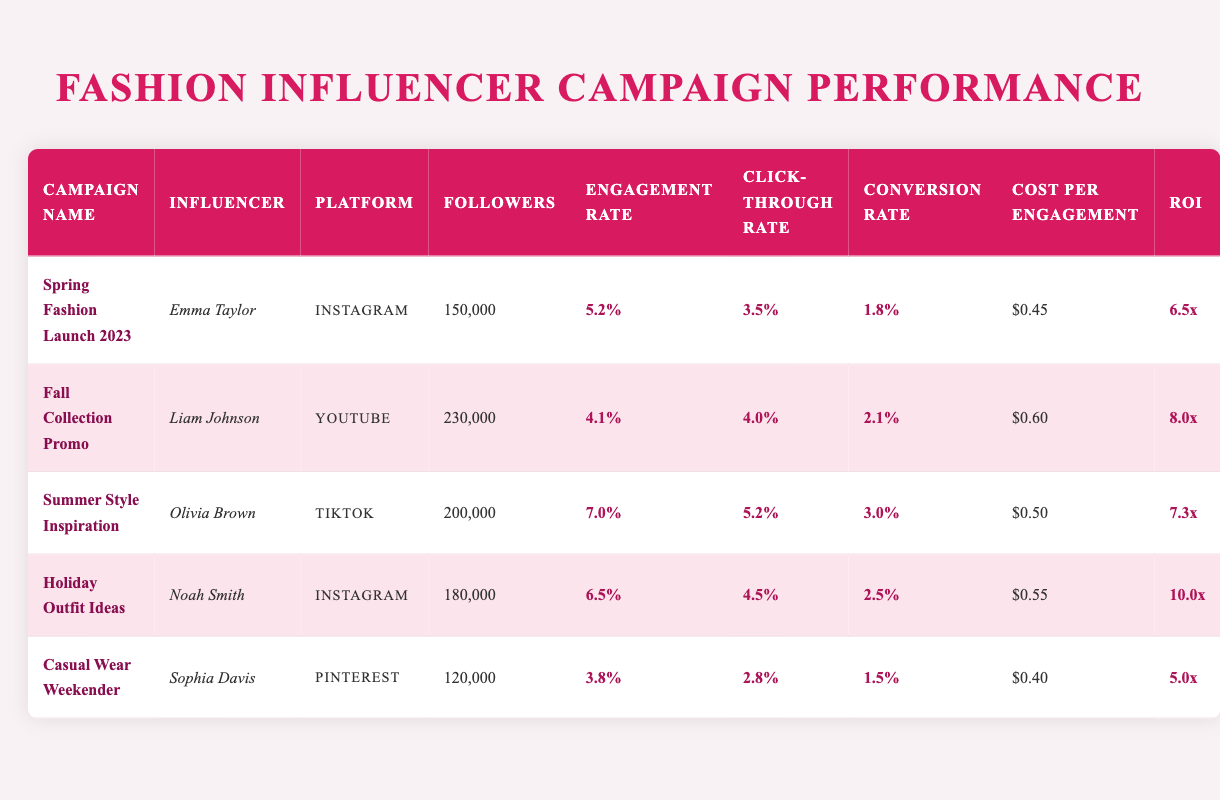What is the Engagement Rate for the "Holiday Outfit Ideas" campaign? The table shows that the Engagement Rate for the "Holiday Outfit Ideas" campaign is listed under that campaign's row. Referring to the table, this value is 6.5%.
Answer: 6.5% Which influencer had the highest Conversion Rate? To determine this, we look at the Conversion Rates for each campaign. Comparing the values in the table, Olivia Brown has the highest Conversion Rate at 3.0%.
Answer: Olivia Brown What is the average Cost Per Engagement for all campaigns? By summing the Cost Per Engagements: 0.45 + 0.60 + 0.50 + 0.55 + 0.40 = 2.50. There are 5 campaigns, so we divide this sum by 5 to get the average: 2.50 / 5 = 0.50.
Answer: 0.50 Did Emma Taylor achieve a higher engagement rate than Liam Johnson? The Engagement Rate for Emma Taylor is 5.2% while Liam Johnson's Engagement Rate is 4.1%. Since 5.2% is greater than 4.1%, the statement is true.
Answer: Yes What is the total number of followers across all campaigns? We need to add the number of followers from each campaign: 150000 + 230000 + 200000 + 180000 + 120000 = 1080000.
Answer: 1,080,000 Which platform had the lowest Engagement Rate in the table? By comparing Engagement Rates for each platform in the table, we can see that Pinterest has the lowest Engagement Rate at 3.8%, associated with the "Casual Wear Weekender" campaign.
Answer: Pinterest What is the difference in Return on Investment between the "Fall Collection Promo" and "Casual Wear Weekender" campaigns? The ROI for "Fall Collection Promo" is 8.0 and for "Casual Wear Weekender" is 5.0. To find the difference, we subtract: 8.0 - 5.0 = 3.0.
Answer: 3.0 Is the Click-Through Rate for "Summer Style Inspiration" higher than the average Click-Through Rate across all campaigns? First, we find the Click-Through Rate for "Summer Style Inspiration," which is 5.2%. Next, we calculate the average Click-Through Rate: (3.5 + 4.0 + 5.2 + 4.5 + 2.8) / 5 = 4.0%. Since 5.2% is higher than 4.0%, the answer is yes.
Answer: Yes Which campaign had the highest Return on Investment (ROI)? The table shows the ROI values for each campaign. The "Holiday Outfit Ideas" campaign has the highest ROI at 10.0.
Answer: Holiday Outfit Ideas 